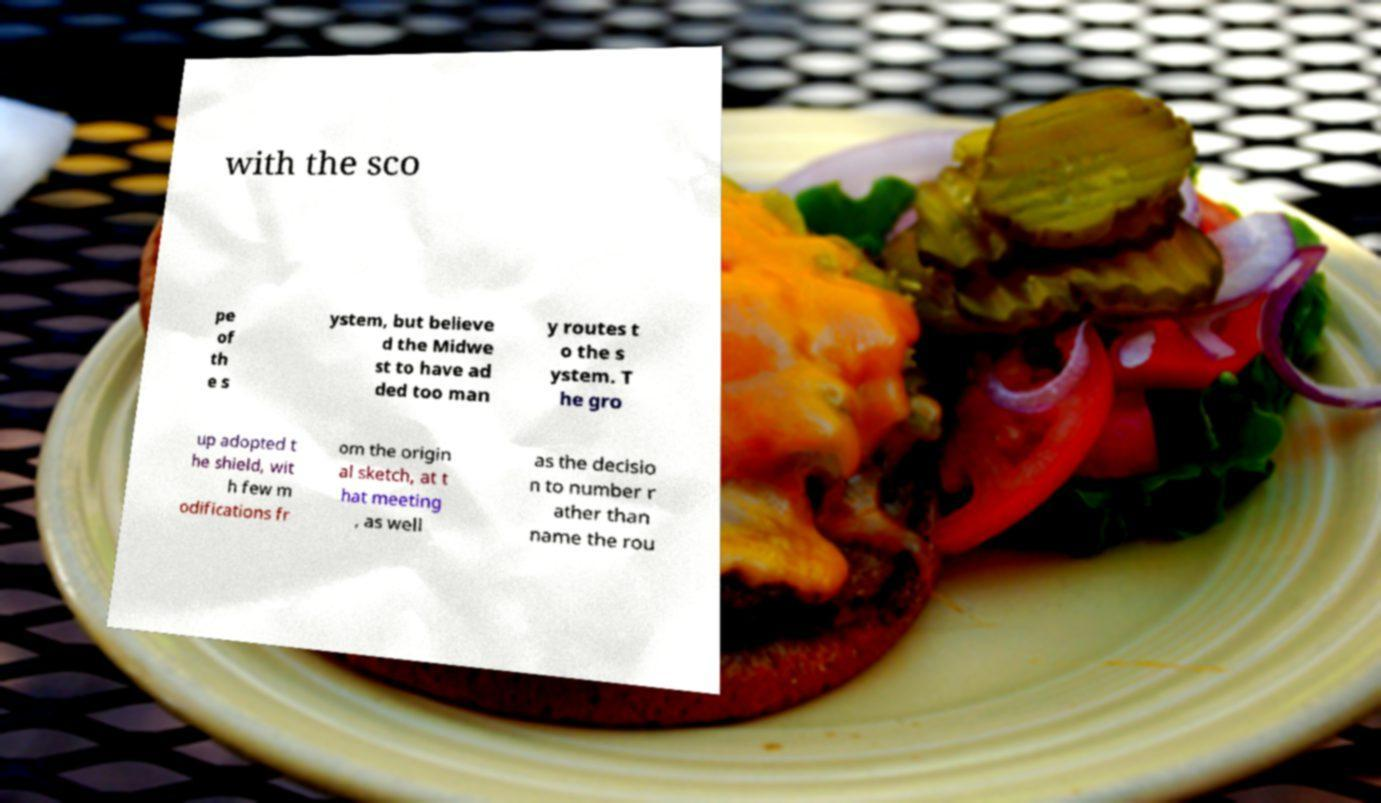Could you extract and type out the text from this image? with the sco pe of th e s ystem, but believe d the Midwe st to have ad ded too man y routes t o the s ystem. T he gro up adopted t he shield, wit h few m odifications fr om the origin al sketch, at t hat meeting , as well as the decisio n to number r ather than name the rou 